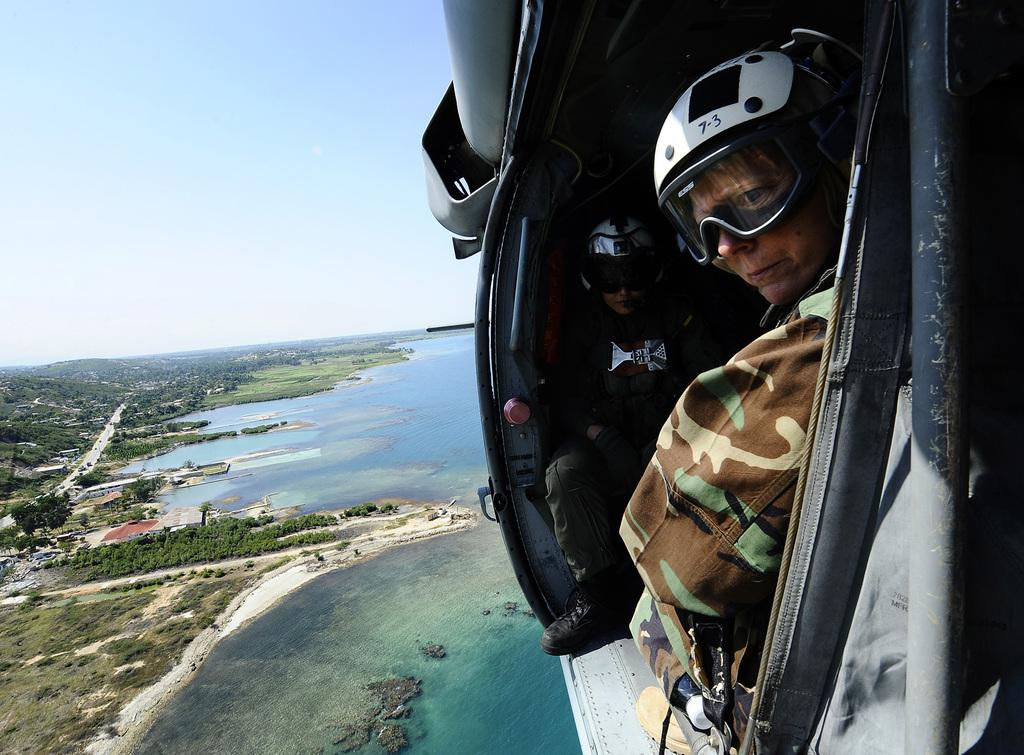How many people are in the helicopter in the image? There are two persons in the helicopter in the image. What is the location of the helicopter in the image? The helicopter is above water in the image. What can be seen on the left side of the image? There are trees on the left side of the image. What is visible at the top of the image? The sky is visible at the top of the image. What type of pot is being used by the porter in the scene? There is no pot or porter present in the image; it features a helicopter above water with two persons inside. 